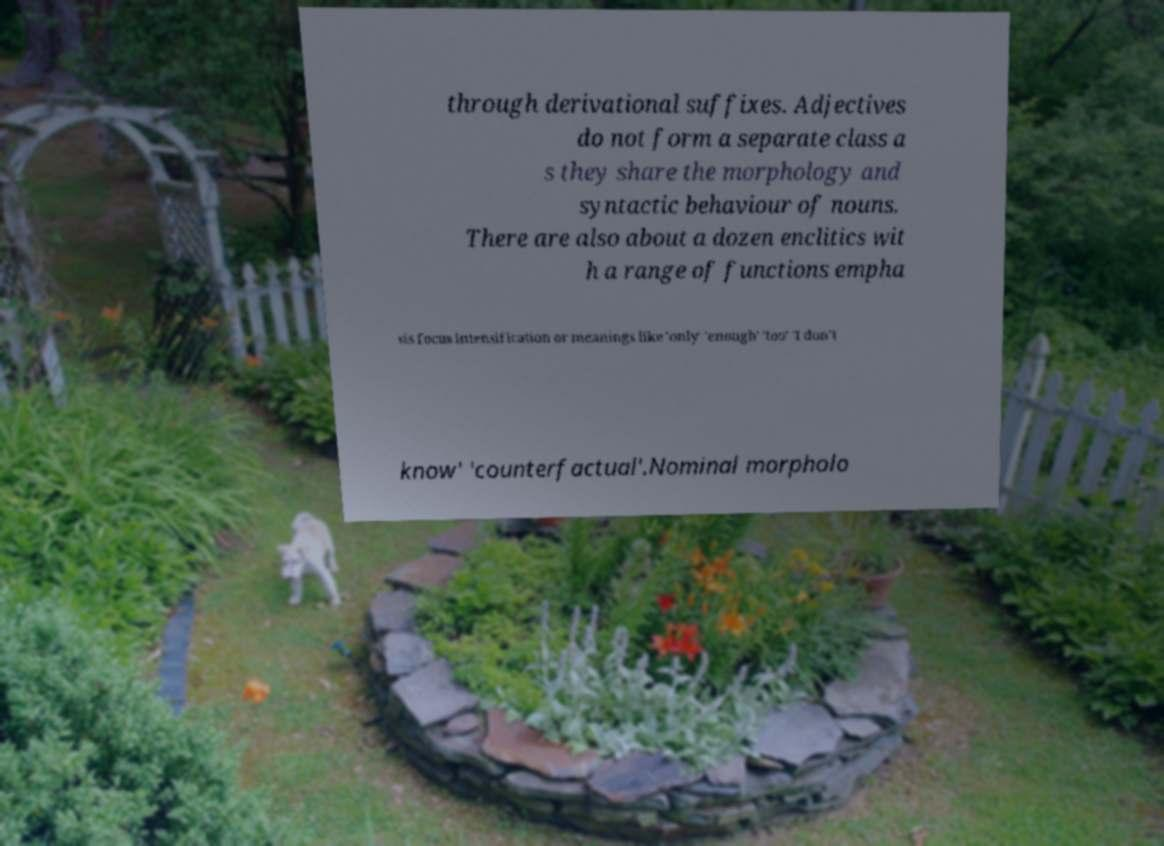There's text embedded in this image that I need extracted. Can you transcribe it verbatim? through derivational suffixes. Adjectives do not form a separate class a s they share the morphology and syntactic behaviour of nouns. There are also about a dozen enclitics wit h a range of functions empha sis focus intensification or meanings like 'only' 'enough' 'too' 'I don't know' 'counterfactual'.Nominal morpholo 